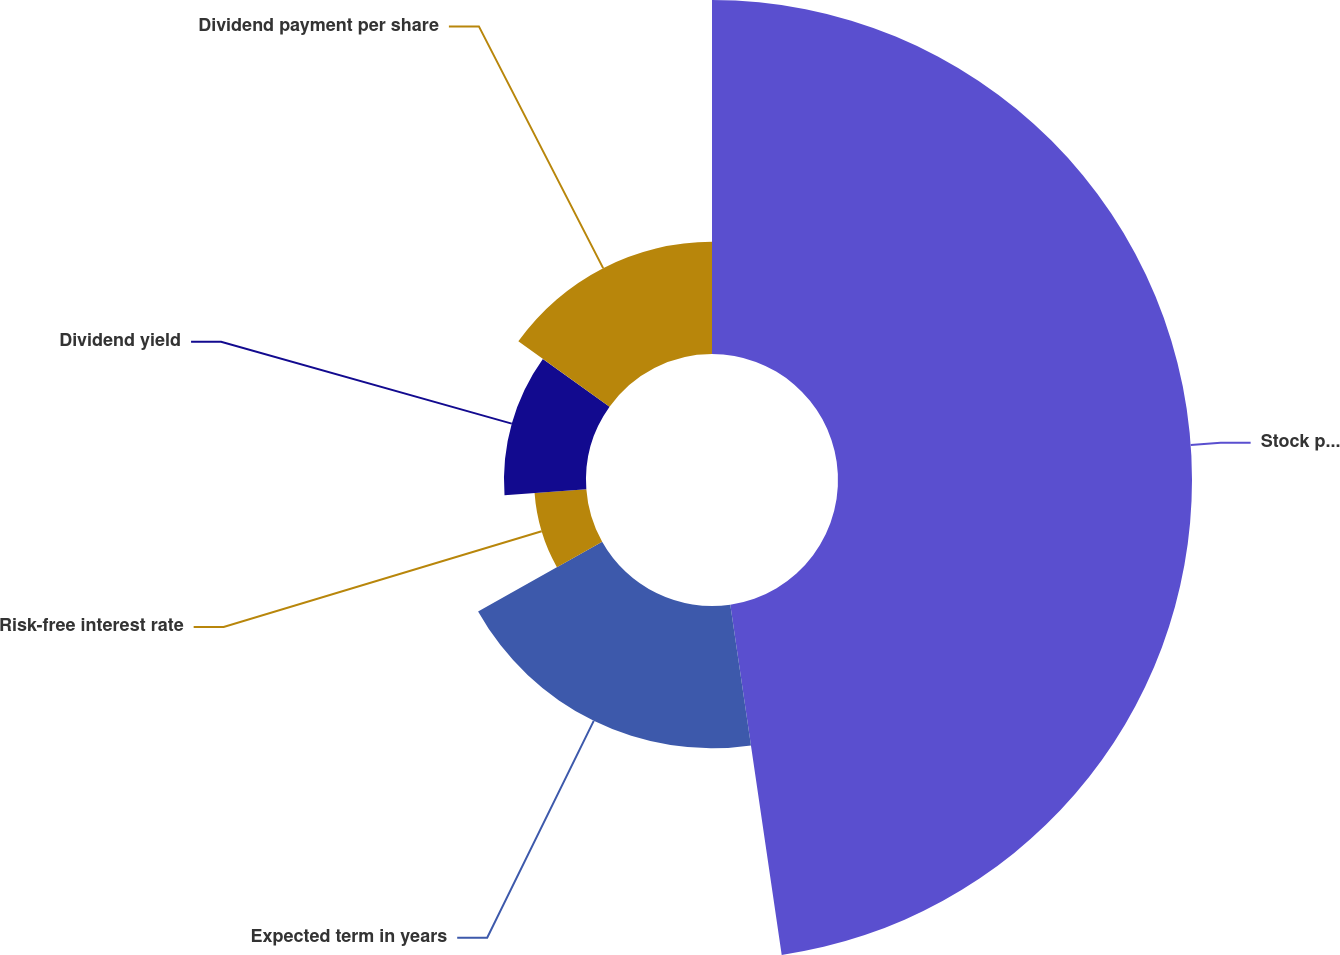Convert chart to OTSL. <chart><loc_0><loc_0><loc_500><loc_500><pie_chart><fcel>Stock price volatility<fcel>Expected term in years<fcel>Risk-free interest rate<fcel>Dividend yield<fcel>Dividend payment per share<nl><fcel>47.68%<fcel>19.17%<fcel>6.99%<fcel>11.05%<fcel>15.11%<nl></chart> 